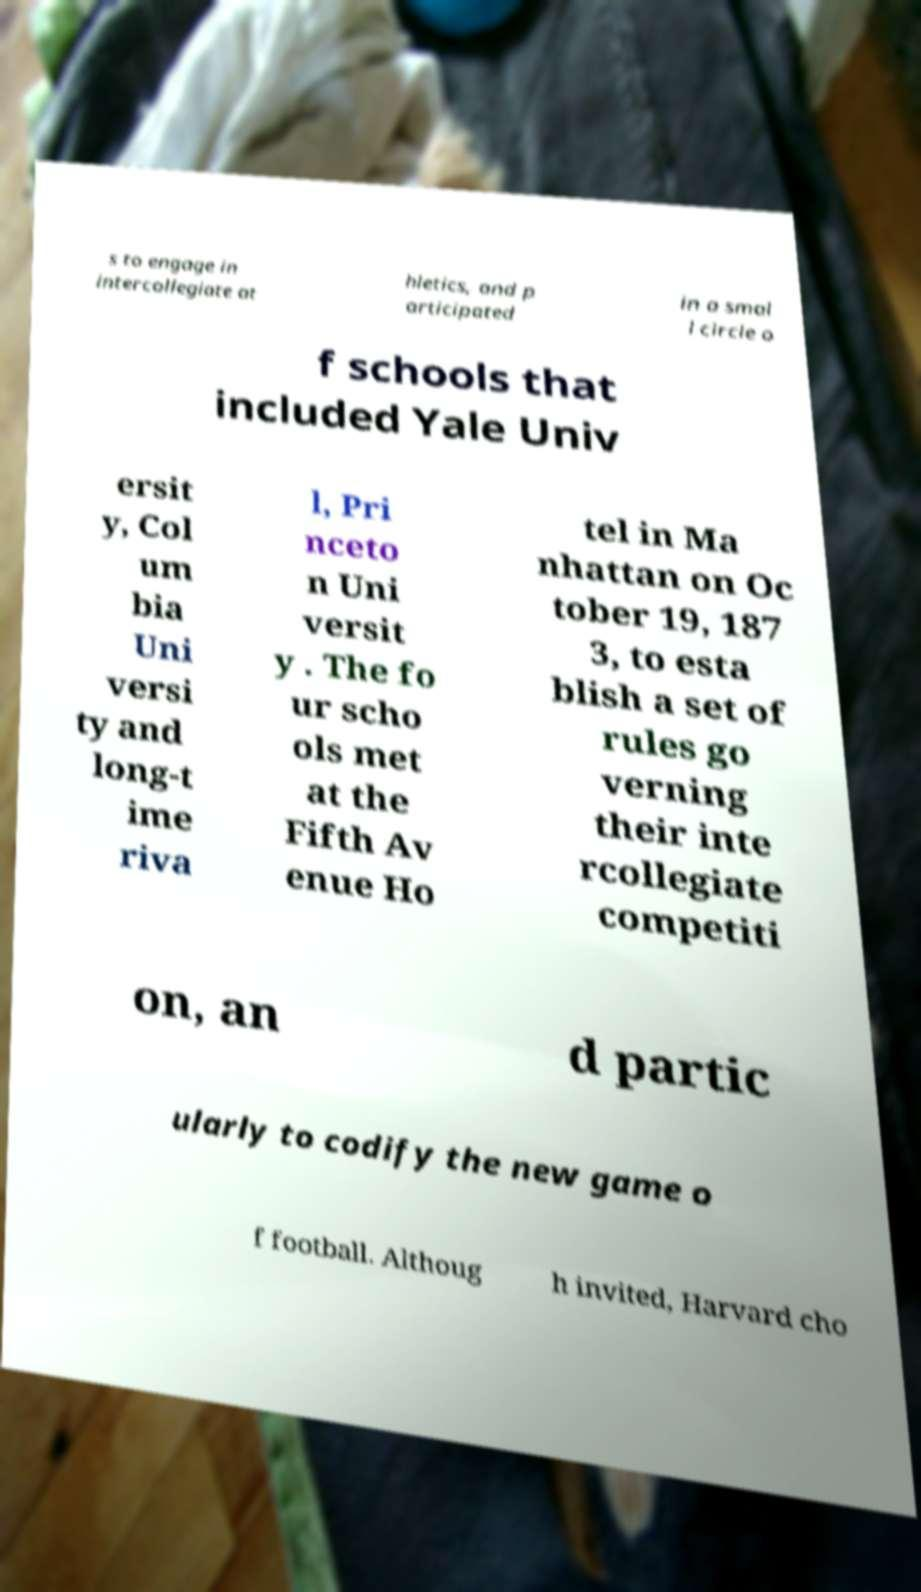Can you accurately transcribe the text from the provided image for me? s to engage in intercollegiate at hletics, and p articipated in a smal l circle o f schools that included Yale Univ ersit y, Col um bia Uni versi ty and long-t ime riva l, Pri nceto n Uni versit y . The fo ur scho ols met at the Fifth Av enue Ho tel in Ma nhattan on Oc tober 19, 187 3, to esta blish a set of rules go verning their inte rcollegiate competiti on, an d partic ularly to codify the new game o f football. Althoug h invited, Harvard cho 